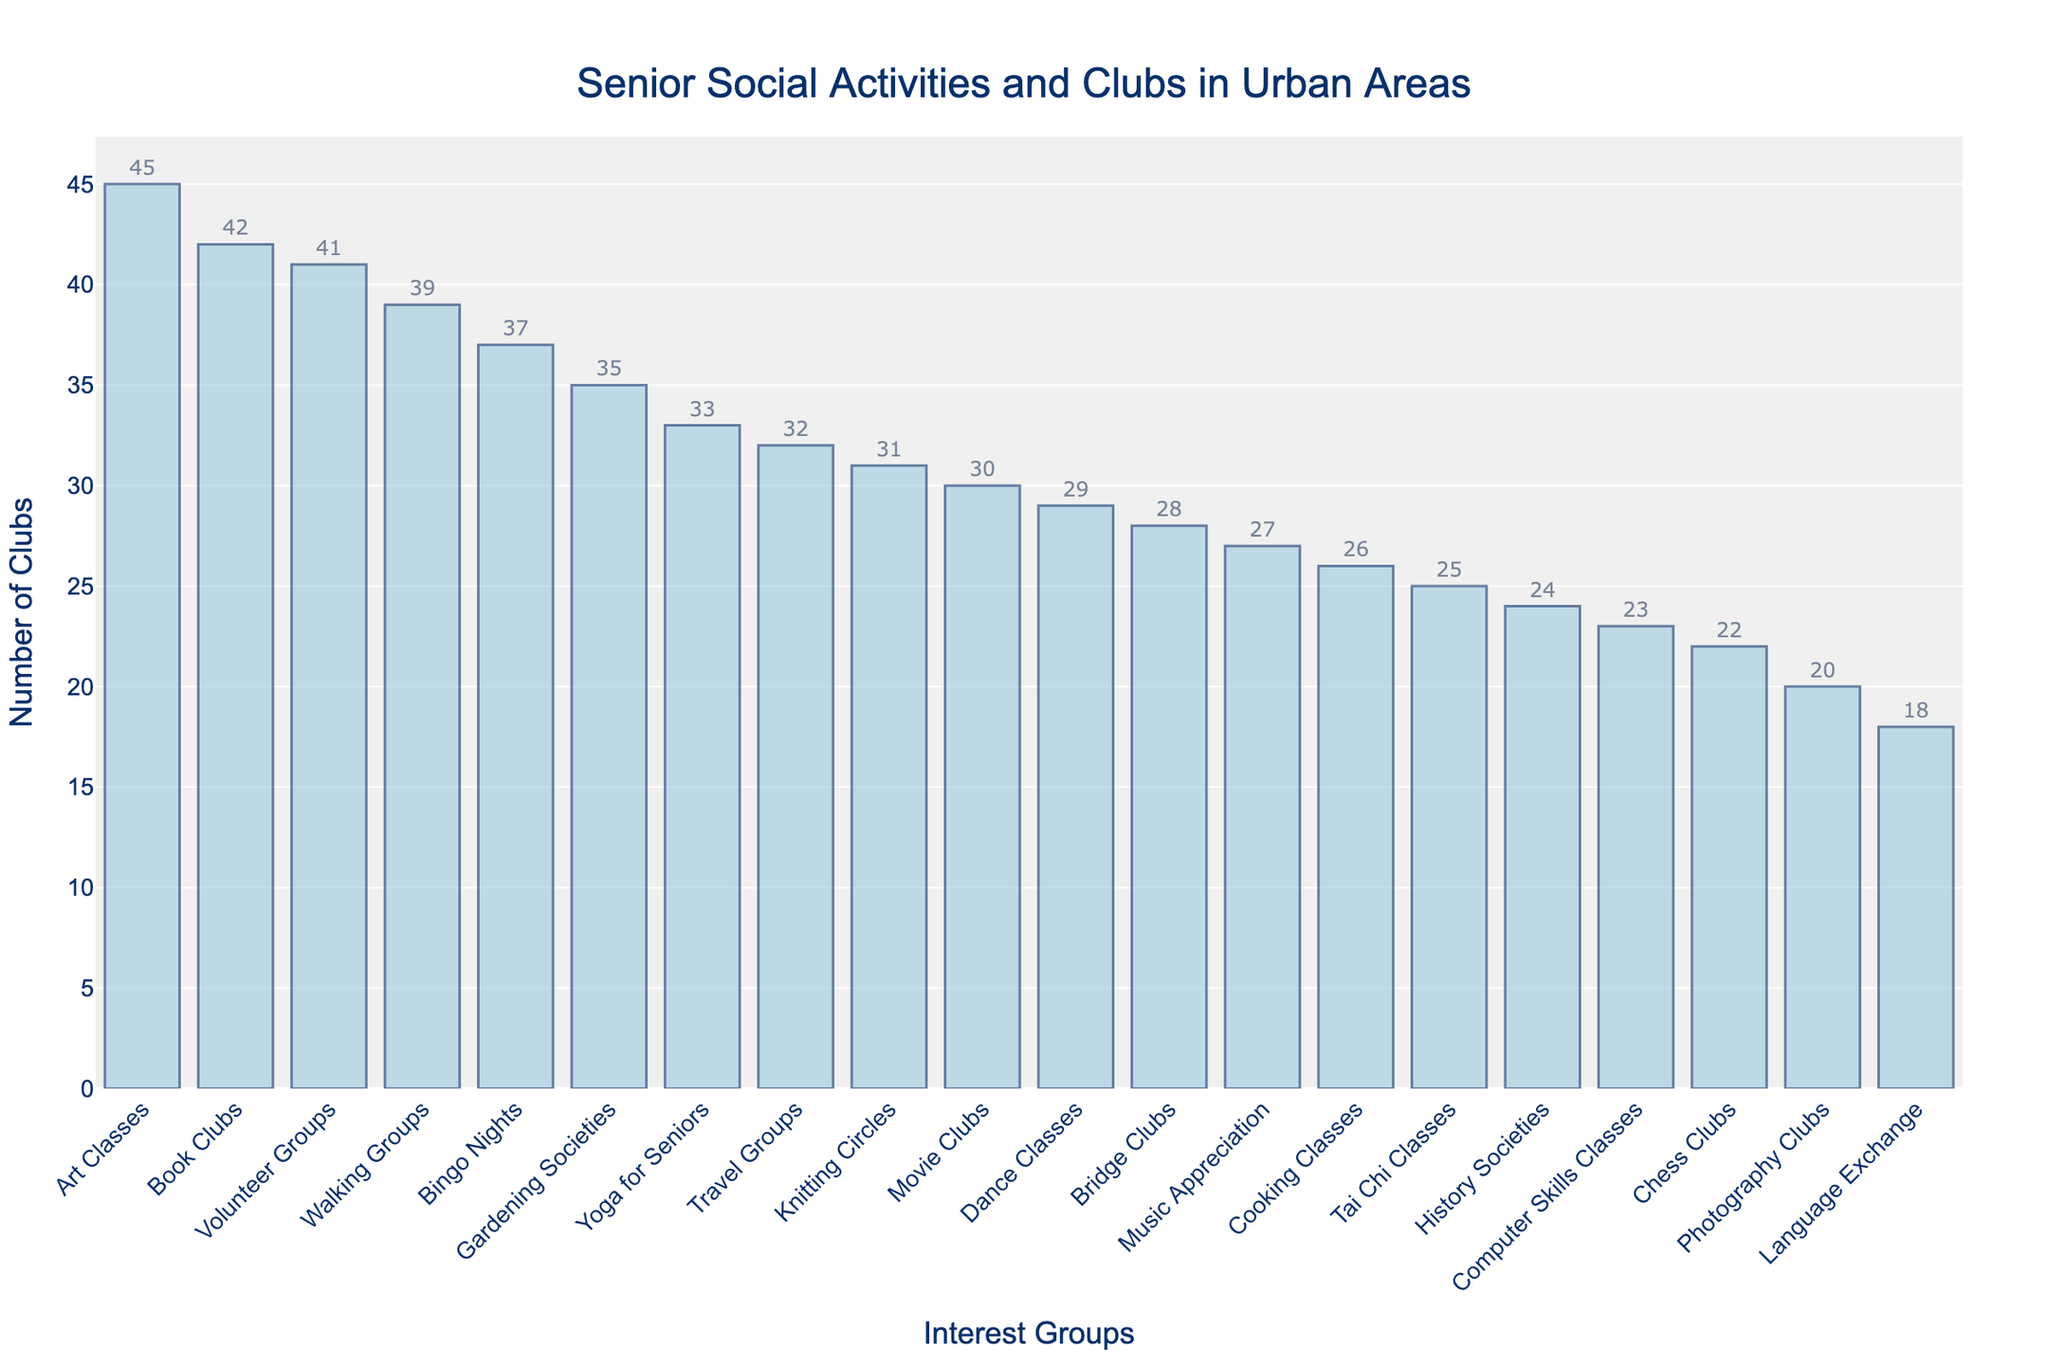Which interest group has the most number of clubs? By inspecting the bar chart, the interest group with the tallest bar represents the most number of clubs. The bar for "Art Classes" is the tallest with 45 clubs.
Answer: Art Classes Which two interest groups have the least number of clubs combined? Looking at the two shortest bars in the chart, "Language Exchange" has 18 clubs and "Photography Clubs" has 20 clubs. The sum of these clubs is 18 + 20 = 38.
Answer: Language Exchange and Photography Clubs How many more clubs do Volunteer Groups have compared to Chess Clubs? First, find the number of clubs for Volunteer Groups (41) and for Chess Clubs (22). Then subtract the smaller number from the larger one: 41 - 22 = 19.
Answer: 19 Which interest group has exactly 31 clubs? Locate the bar with a height corresponding to 31 clubs. The interest group labeled "Knitting Circles" has 31 clubs.
Answer: Knitting Circles Are there more Gardening Societies or Cooking Classes? Compare the heights of the bars for "Gardening Societies" and "Cooking Classes". Gardening Societies has 35 clubs, while Cooking Classes has 26. 35 is greater than 26.
Answer: Gardening Societies What's the combined total number of clubs for Bridge Clubs, Tai Chi Classes, and Yoga for Seniors? Add the number of clubs for each interest group: Bridge Clubs (28) + Tai Chi Classes (25) + Yoga for Seniors (33). The sum is 28 + 25 + 33 = 86.
Answer: 86 How many interest groups have more than 30 clubs? Count the bars with heights greater than 30. There are 8 such groups: Book Clubs (42), Gardening Societies (35), Walking Groups (39), Art Classes (45), Bingo Nights (37), Yoga for Seniors (33), Knitting Circles (31), and Volunteer Groups (41).
Answer: 8 Which interest group has clubs that are almost half the number of Art Classes? Art Classes have 45 clubs. Half of 45 is 22.5. The closest value to 22.5 is 22 clubs, which corresponds to Chess Clubs.
Answer: Chess Clubs Compare the number of clubs in Movie Clubs and Dance Classes. Which one has more? By comparing the heights of the bars, Movie Clubs have 30 clubs and Dance Classes have 29 clubs. 30 is greater than 29.
Answer: Movie Clubs If you were to join a senior social club, which interest group offers the fourth most number of clubs? Arrange the interest groups by the number of clubs in descending order. The fourth highest number is Walking Groups with 39 clubs.
Answer: Walking Groups 